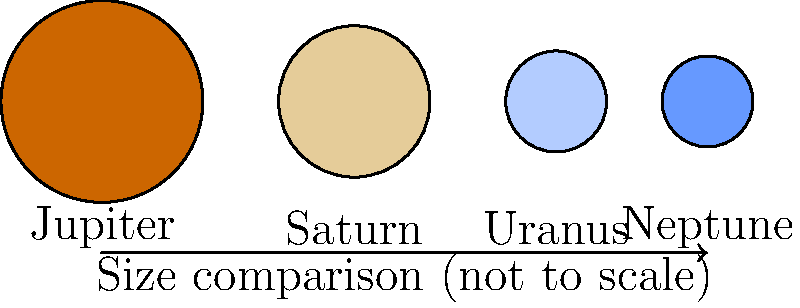In our journey through the solar system, we encounter various celestial bodies that inspire awe and wonder. Looking at the image of the gas giants, which planet is the largest, symbolizing the grandeur of our cosmic neighborhood much like the strength of enduring love in a committed relationship? To answer this question, let's analyze the image step-by-step:

1. The image shows four planets: Jupiter, Saturn, Uranus, and Neptune.
2. These planets are known as the gas giants of our solar system.
3. The sizes of the planets in the image are represented by circles of different diameters.
4. Jupiter is depicted with the largest circle, indicating it's the largest planet.
5. Saturn is shown as the second-largest.
6. Uranus and Neptune are illustrated as smaller and more similarly sized planets.

In reality:
- Jupiter has a diameter of about 139,820 km.
- Saturn's diameter is approximately 116,460 km.
- Uranus has a diameter of about 50,724 km.
- Neptune's diameter is around 49,244 km.

Jupiter is significantly larger than the other gas giants, making it stand out as the largest planet in our solar system. Its immense size and presence in the solar system can be seen as a metaphor for the strength and significance of a committed relationship, much like the one described in the persona.
Answer: Jupiter 